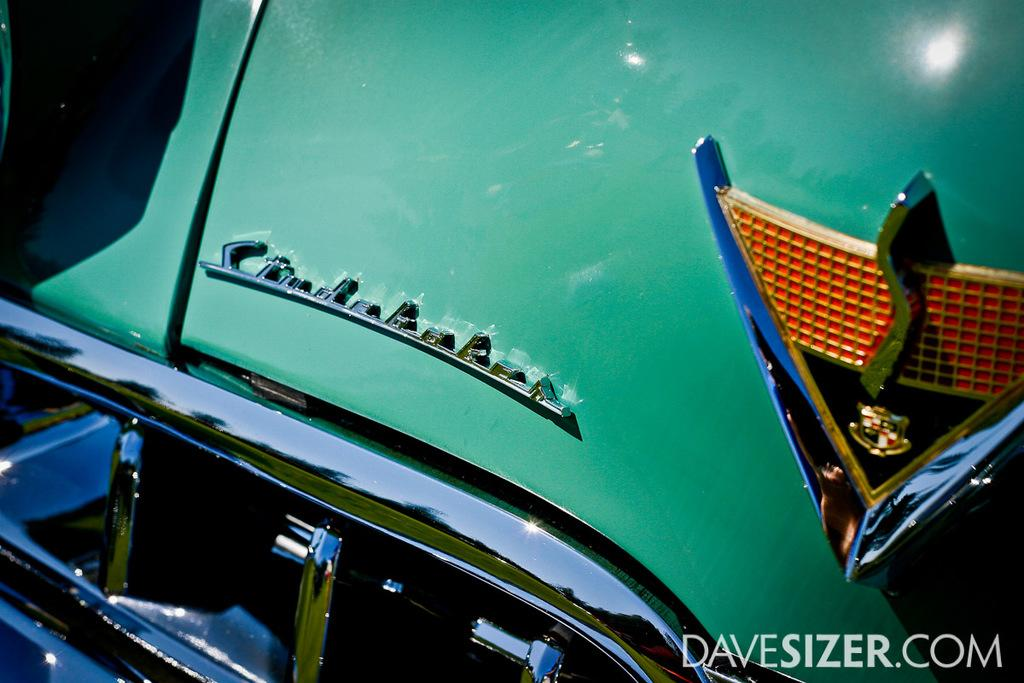What is the main subject of the image? The main subject of the image is a green color car. Can you describe the color of the car in the image? The car in the image is green. Is there any text visible in the image? Yes, there is text in the bottom right corner of the image. How many snakes can be seen slithering around the car in the image? There are no snakes present in the image; it features a green color car with text in the bottom right corner. What type of fang is visible on the car in the image? There is no fang present in the image; it features a green color car with text in the bottom right corner. 